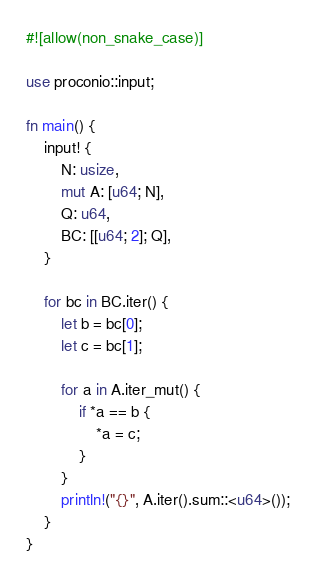Convert code to text. <code><loc_0><loc_0><loc_500><loc_500><_Rust_>#![allow(non_snake_case)]

use proconio::input;

fn main() {
    input! {
        N: usize,
        mut A: [u64; N],
        Q: u64,
        BC: [[u64; 2]; Q],
    }

    for bc in BC.iter() {
        let b = bc[0];
        let c = bc[1];

        for a in A.iter_mut() {
            if *a == b {
                *a = c;
            }
        }
        println!("{}", A.iter().sum::<u64>());
    }
}
</code> 